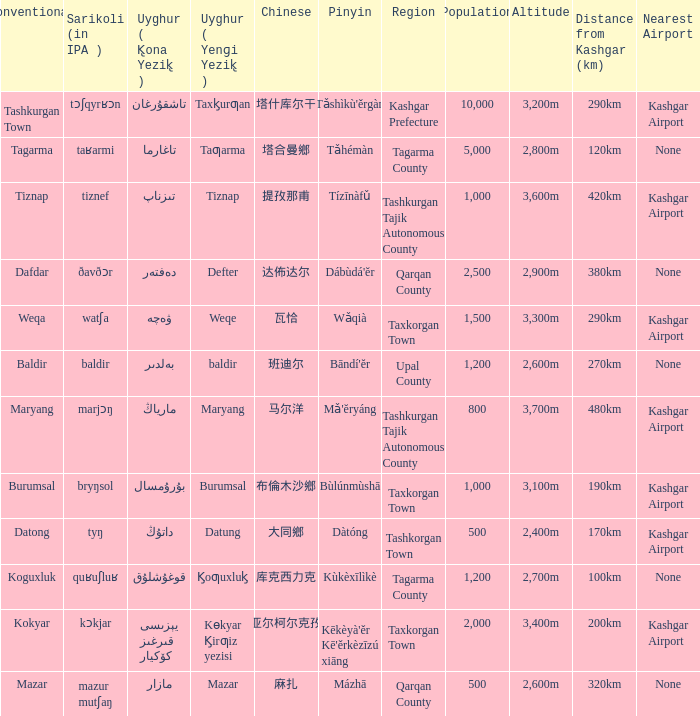Name the pinyin for  kɵkyar k̡irƣiz yezisi Kēkèyà'ěr Kē'ěrkèzīzú xiāng. 